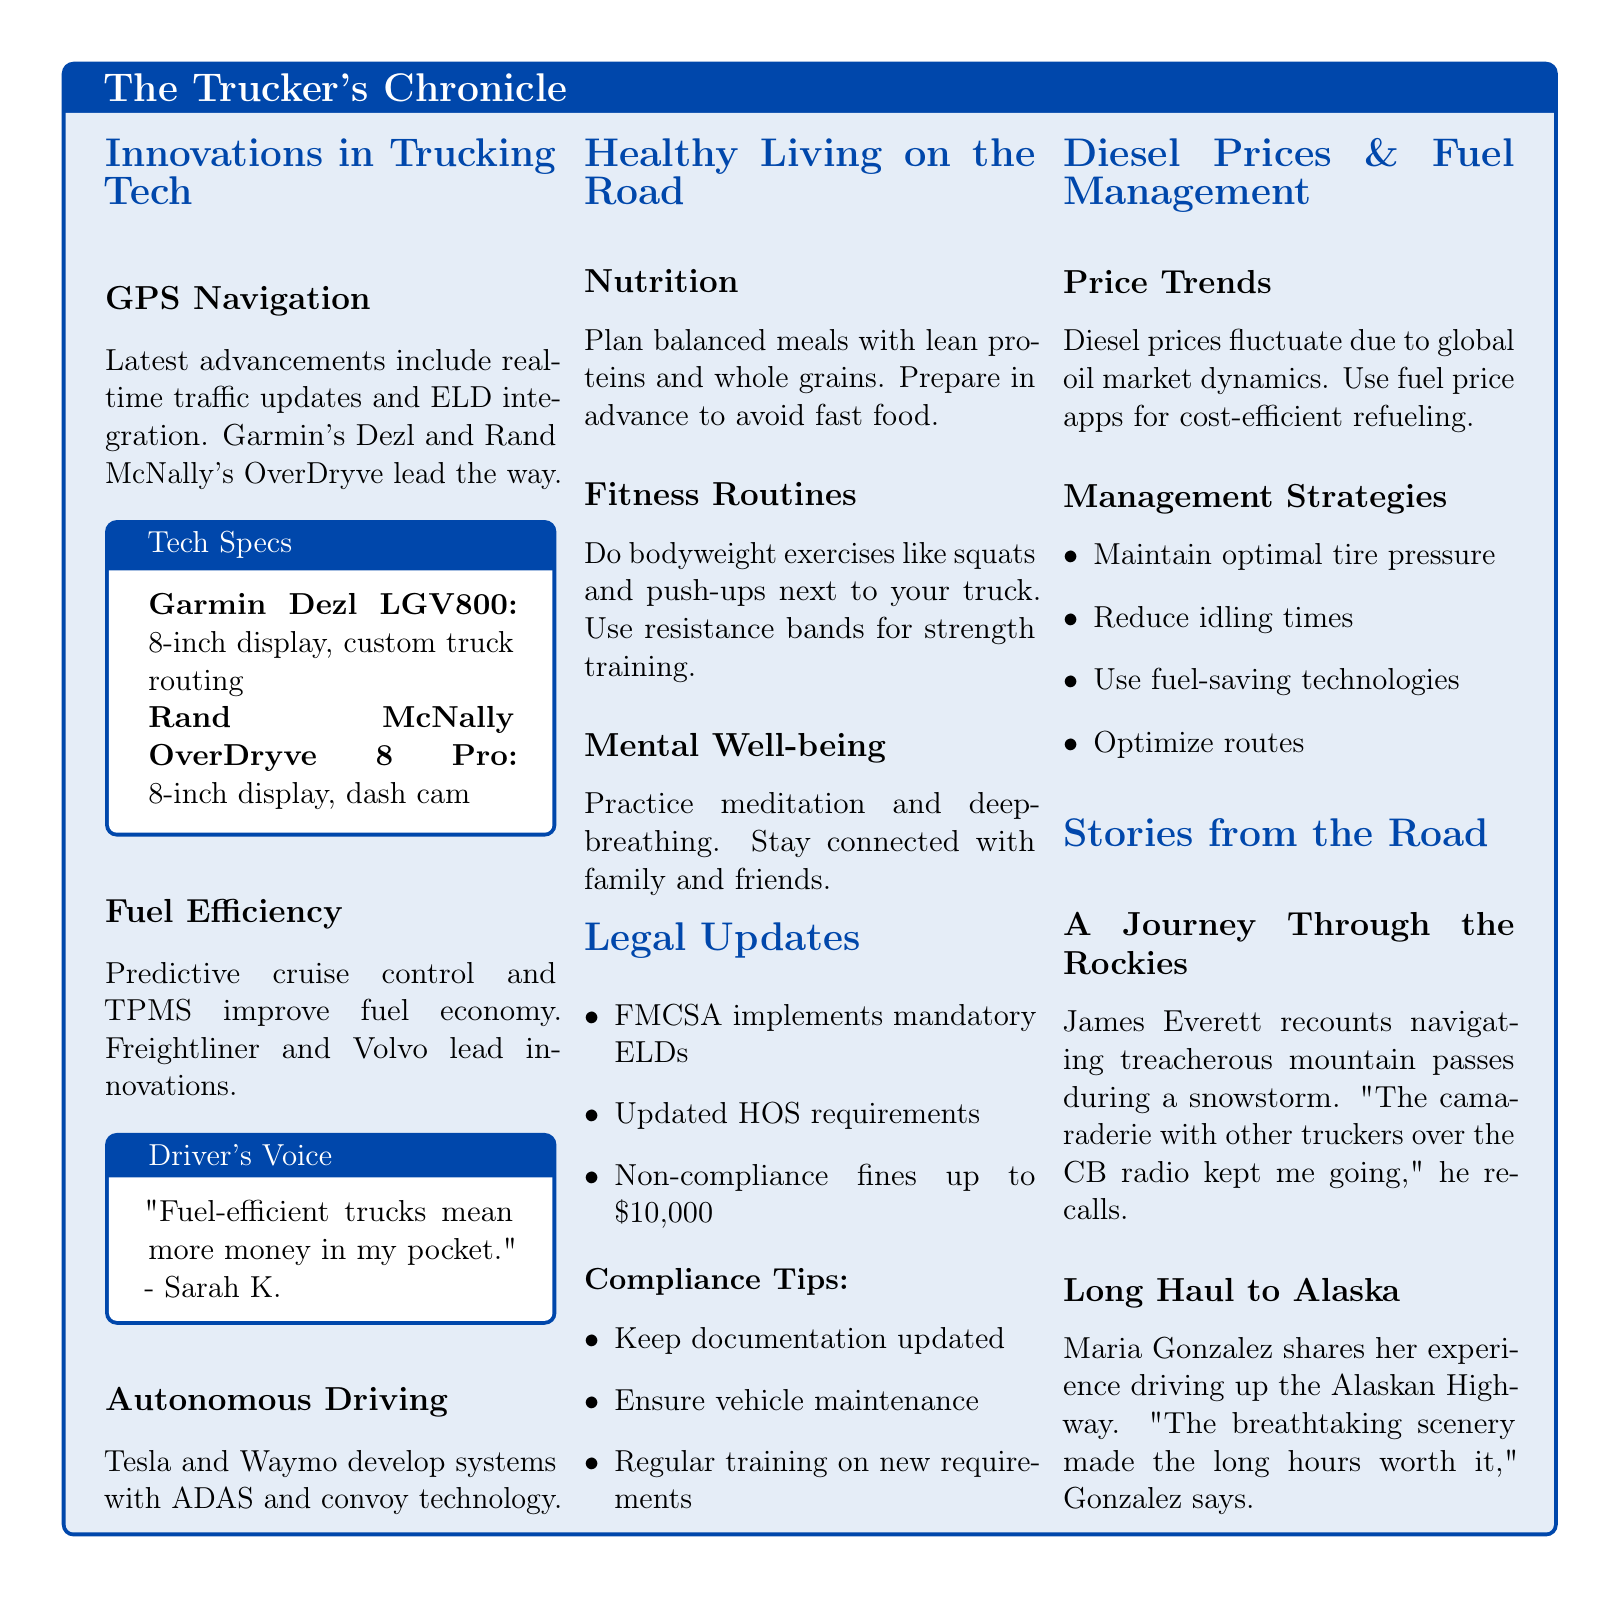What are the latest advancements in GPS navigation? The latest advancements include real-time traffic updates and ELD integration.
Answer: Real-time traffic updates and ELD integration What is the penalty for non-compliance? The document states that non-compliance fines can be up to $10,000.
Answer: $10,000 Which two companies lead innovations in fuel efficiency? The document mentions that Freightliner and Volvo lead innovations.
Answer: Freightliner and Volvo What fitness routine can be done next to a truck? The document suggests doing bodyweight exercises like squats and push-ups.
Answer: Bodyweight exercises like squats and push-ups Who shared their experience driving up the Alaskan Highway? The personal story recounting this experience is shared by Maria Gonzalez.
Answer: Maria Gonzalez What technology is Tesla and Waymo developing? The document states that Tesla and Waymo develop systems with ADAS and convoy technology.
Answer: ADAS and convoy technology What should truckers ensure to stay compliant with legal updates? Truckers should ensure vehicle maintenance to stay compliant.
Answer: Vehicle maintenance How does the document suggest managing diesel prices? The document suggests using fuel price apps for cost-efficient refueling.
Answer: Fuel price apps for cost-efficient refueling What color is used for section backgrounds in healthy living tips? Different color backgrounds are used for each type of tip.
Answer: Different color backgrounds 